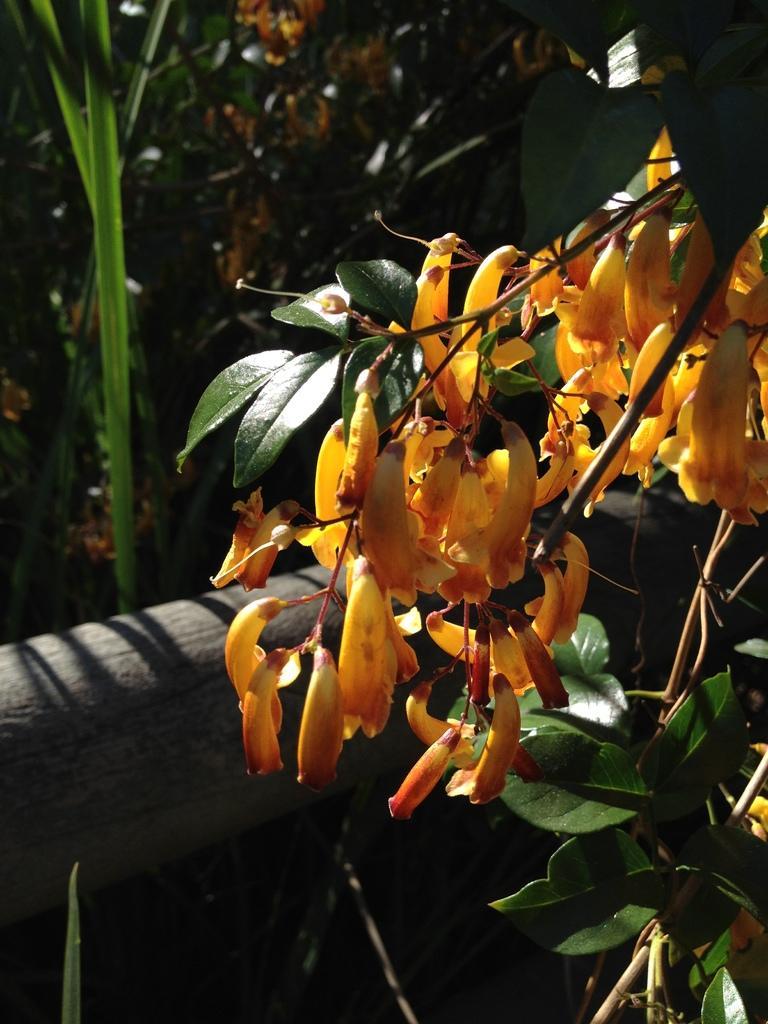Can you describe this image briefly? In this image we can see yellow color flowers which is surrounded by various plants. 